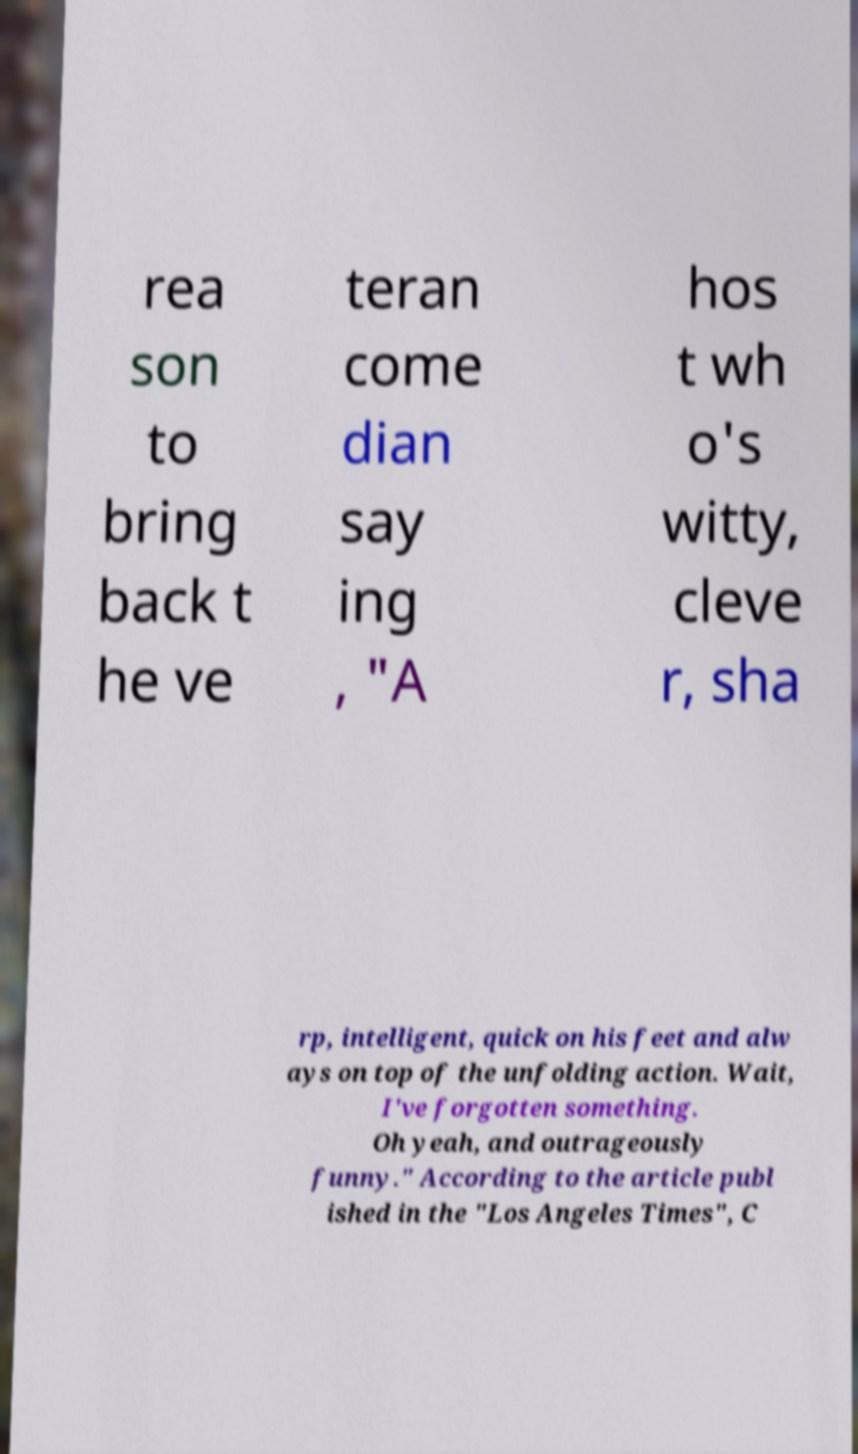Can you accurately transcribe the text from the provided image for me? rea son to bring back t he ve teran come dian say ing , "A hos t wh o's witty, cleve r, sha rp, intelligent, quick on his feet and alw ays on top of the unfolding action. Wait, I've forgotten something. Oh yeah, and outrageously funny." According to the article publ ished in the "Los Angeles Times", C 